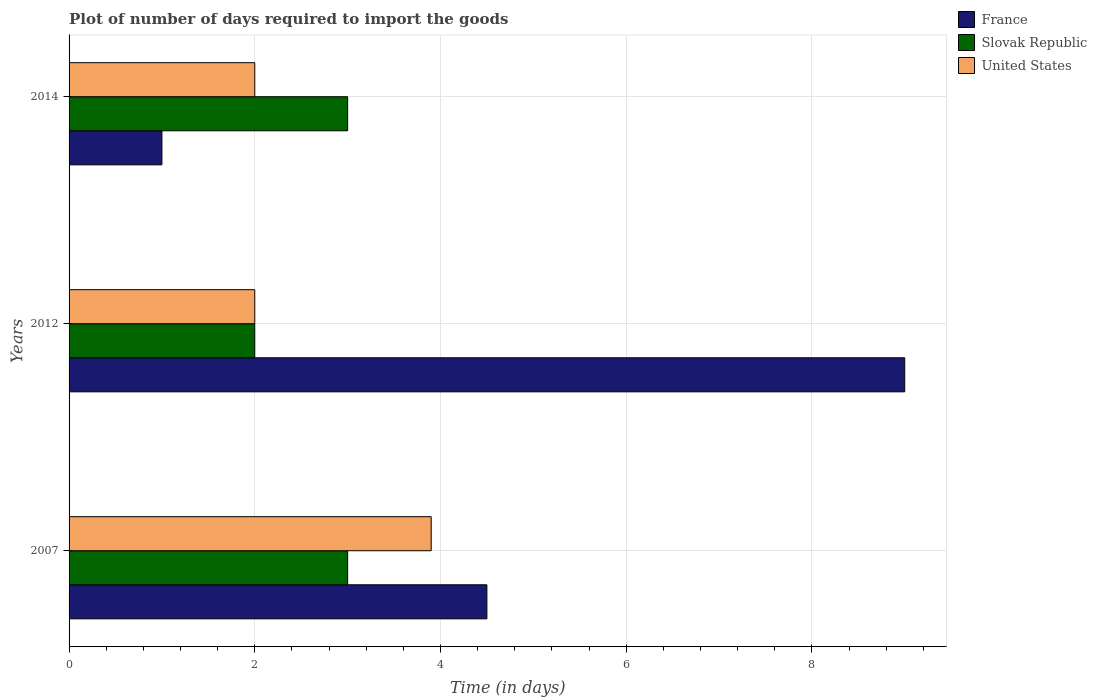How many bars are there on the 2nd tick from the top?
Your answer should be very brief. 3. What is the label of the 2nd group of bars from the top?
Your answer should be very brief. 2012. What is the time required to import goods in Slovak Republic in 2007?
Offer a very short reply. 3. Across all years, what is the minimum time required to import goods in Slovak Republic?
Make the answer very short. 2. What is the total time required to import goods in Slovak Republic in the graph?
Ensure brevity in your answer.  8. What is the difference between the time required to import goods in United States in 2007 and that in 2014?
Make the answer very short. 1.9. What is the difference between the time required to import goods in Slovak Republic in 2014 and the time required to import goods in France in 2007?
Your answer should be very brief. -1.5. What is the average time required to import goods in United States per year?
Keep it short and to the point. 2.63. In the year 2012, what is the difference between the time required to import goods in United States and time required to import goods in France?
Make the answer very short. -7. What is the ratio of the time required to import goods in Slovak Republic in 2007 to that in 2014?
Provide a succinct answer. 1. What is the difference between the highest and the lowest time required to import goods in United States?
Provide a short and direct response. 1.9. In how many years, is the time required to import goods in France greater than the average time required to import goods in France taken over all years?
Offer a very short reply. 1. What does the 1st bar from the top in 2012 represents?
Offer a terse response. United States. What does the 2nd bar from the bottom in 2012 represents?
Your answer should be compact. Slovak Republic. Is it the case that in every year, the sum of the time required to import goods in Slovak Republic and time required to import goods in France is greater than the time required to import goods in United States?
Provide a succinct answer. Yes. How many bars are there?
Your answer should be compact. 9. Are all the bars in the graph horizontal?
Keep it short and to the point. Yes. Where does the legend appear in the graph?
Provide a short and direct response. Top right. What is the title of the graph?
Offer a terse response. Plot of number of days required to import the goods. Does "Azerbaijan" appear as one of the legend labels in the graph?
Provide a short and direct response. No. What is the label or title of the X-axis?
Offer a very short reply. Time (in days). What is the label or title of the Y-axis?
Give a very brief answer. Years. What is the Time (in days) of Slovak Republic in 2007?
Offer a terse response. 3. What is the Time (in days) in United States in 2007?
Your answer should be compact. 3.9. What is the Time (in days) in France in 2012?
Provide a short and direct response. 9. What is the Time (in days) in United States in 2012?
Provide a short and direct response. 2. What is the Time (in days) in United States in 2014?
Offer a very short reply. 2. Across all years, what is the maximum Time (in days) of Slovak Republic?
Provide a short and direct response. 3. Across all years, what is the maximum Time (in days) of United States?
Offer a terse response. 3.9. Across all years, what is the minimum Time (in days) of France?
Give a very brief answer. 1. Across all years, what is the minimum Time (in days) of United States?
Provide a short and direct response. 2. What is the total Time (in days) in France in the graph?
Ensure brevity in your answer.  14.5. What is the total Time (in days) of Slovak Republic in the graph?
Keep it short and to the point. 8. What is the difference between the Time (in days) in United States in 2007 and that in 2012?
Provide a succinct answer. 1.9. What is the difference between the Time (in days) of Slovak Republic in 2007 and that in 2014?
Keep it short and to the point. 0. What is the difference between the Time (in days) in France in 2012 and that in 2014?
Provide a short and direct response. 8. What is the difference between the Time (in days) in United States in 2012 and that in 2014?
Your answer should be compact. 0. What is the difference between the Time (in days) in France in 2007 and the Time (in days) in United States in 2014?
Offer a very short reply. 2.5. What is the difference between the Time (in days) of France in 2012 and the Time (in days) of Slovak Republic in 2014?
Your answer should be very brief. 6. What is the difference between the Time (in days) of France in 2012 and the Time (in days) of United States in 2014?
Provide a succinct answer. 7. What is the average Time (in days) in France per year?
Offer a terse response. 4.83. What is the average Time (in days) in Slovak Republic per year?
Offer a very short reply. 2.67. What is the average Time (in days) in United States per year?
Your response must be concise. 2.63. In the year 2007, what is the difference between the Time (in days) in Slovak Republic and Time (in days) in United States?
Your response must be concise. -0.9. In the year 2012, what is the difference between the Time (in days) of Slovak Republic and Time (in days) of United States?
Give a very brief answer. 0. In the year 2014, what is the difference between the Time (in days) in France and Time (in days) in United States?
Provide a short and direct response. -1. What is the ratio of the Time (in days) of France in 2007 to that in 2012?
Provide a short and direct response. 0.5. What is the ratio of the Time (in days) of Slovak Republic in 2007 to that in 2012?
Offer a very short reply. 1.5. What is the ratio of the Time (in days) in United States in 2007 to that in 2012?
Give a very brief answer. 1.95. What is the ratio of the Time (in days) in France in 2007 to that in 2014?
Keep it short and to the point. 4.5. What is the ratio of the Time (in days) in United States in 2007 to that in 2014?
Your response must be concise. 1.95. What is the ratio of the Time (in days) in France in 2012 to that in 2014?
Make the answer very short. 9. What is the difference between the highest and the second highest Time (in days) of France?
Offer a terse response. 4.5. What is the difference between the highest and the second highest Time (in days) of United States?
Make the answer very short. 1.9. What is the difference between the highest and the lowest Time (in days) of Slovak Republic?
Offer a very short reply. 1. What is the difference between the highest and the lowest Time (in days) in United States?
Your answer should be very brief. 1.9. 